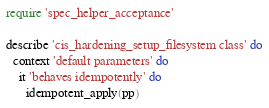Convert code to text. <code><loc_0><loc_0><loc_500><loc_500><_Ruby_>require 'spec_helper_acceptance'

describe 'cis_hardening_setup_filesystem class' do
  context 'default parameters' do
    it 'behaves idempotently' do
      idempotent_apply(pp)</code> 